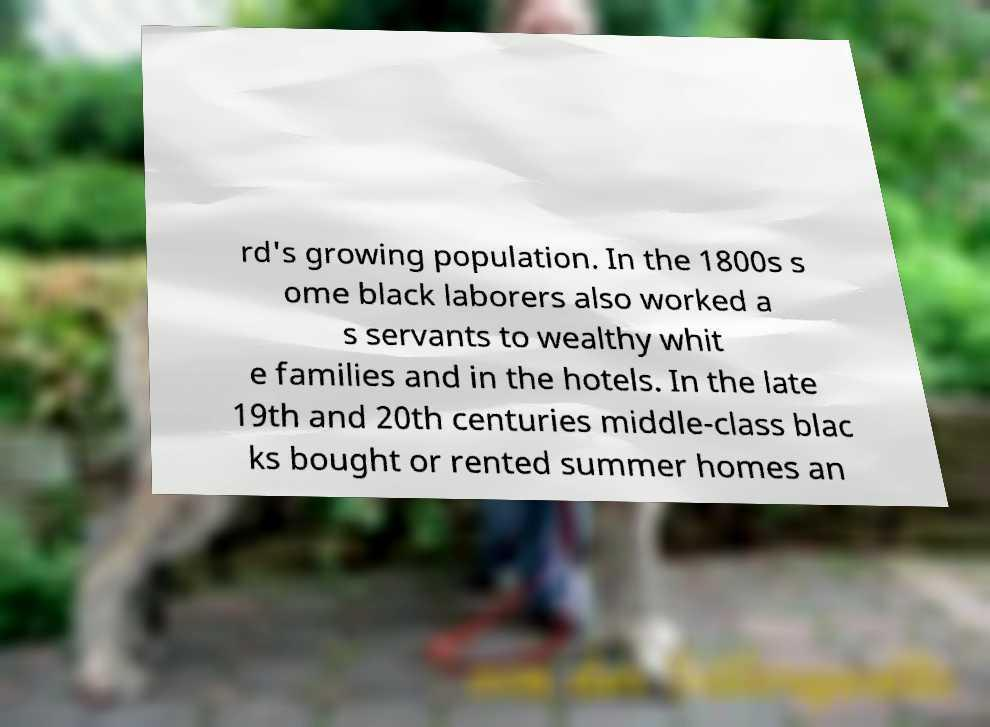For documentation purposes, I need the text within this image transcribed. Could you provide that? rd's growing population. In the 1800s s ome black laborers also worked a s servants to wealthy whit e families and in the hotels. In the late 19th and 20th centuries middle-class blac ks bought or rented summer homes an 